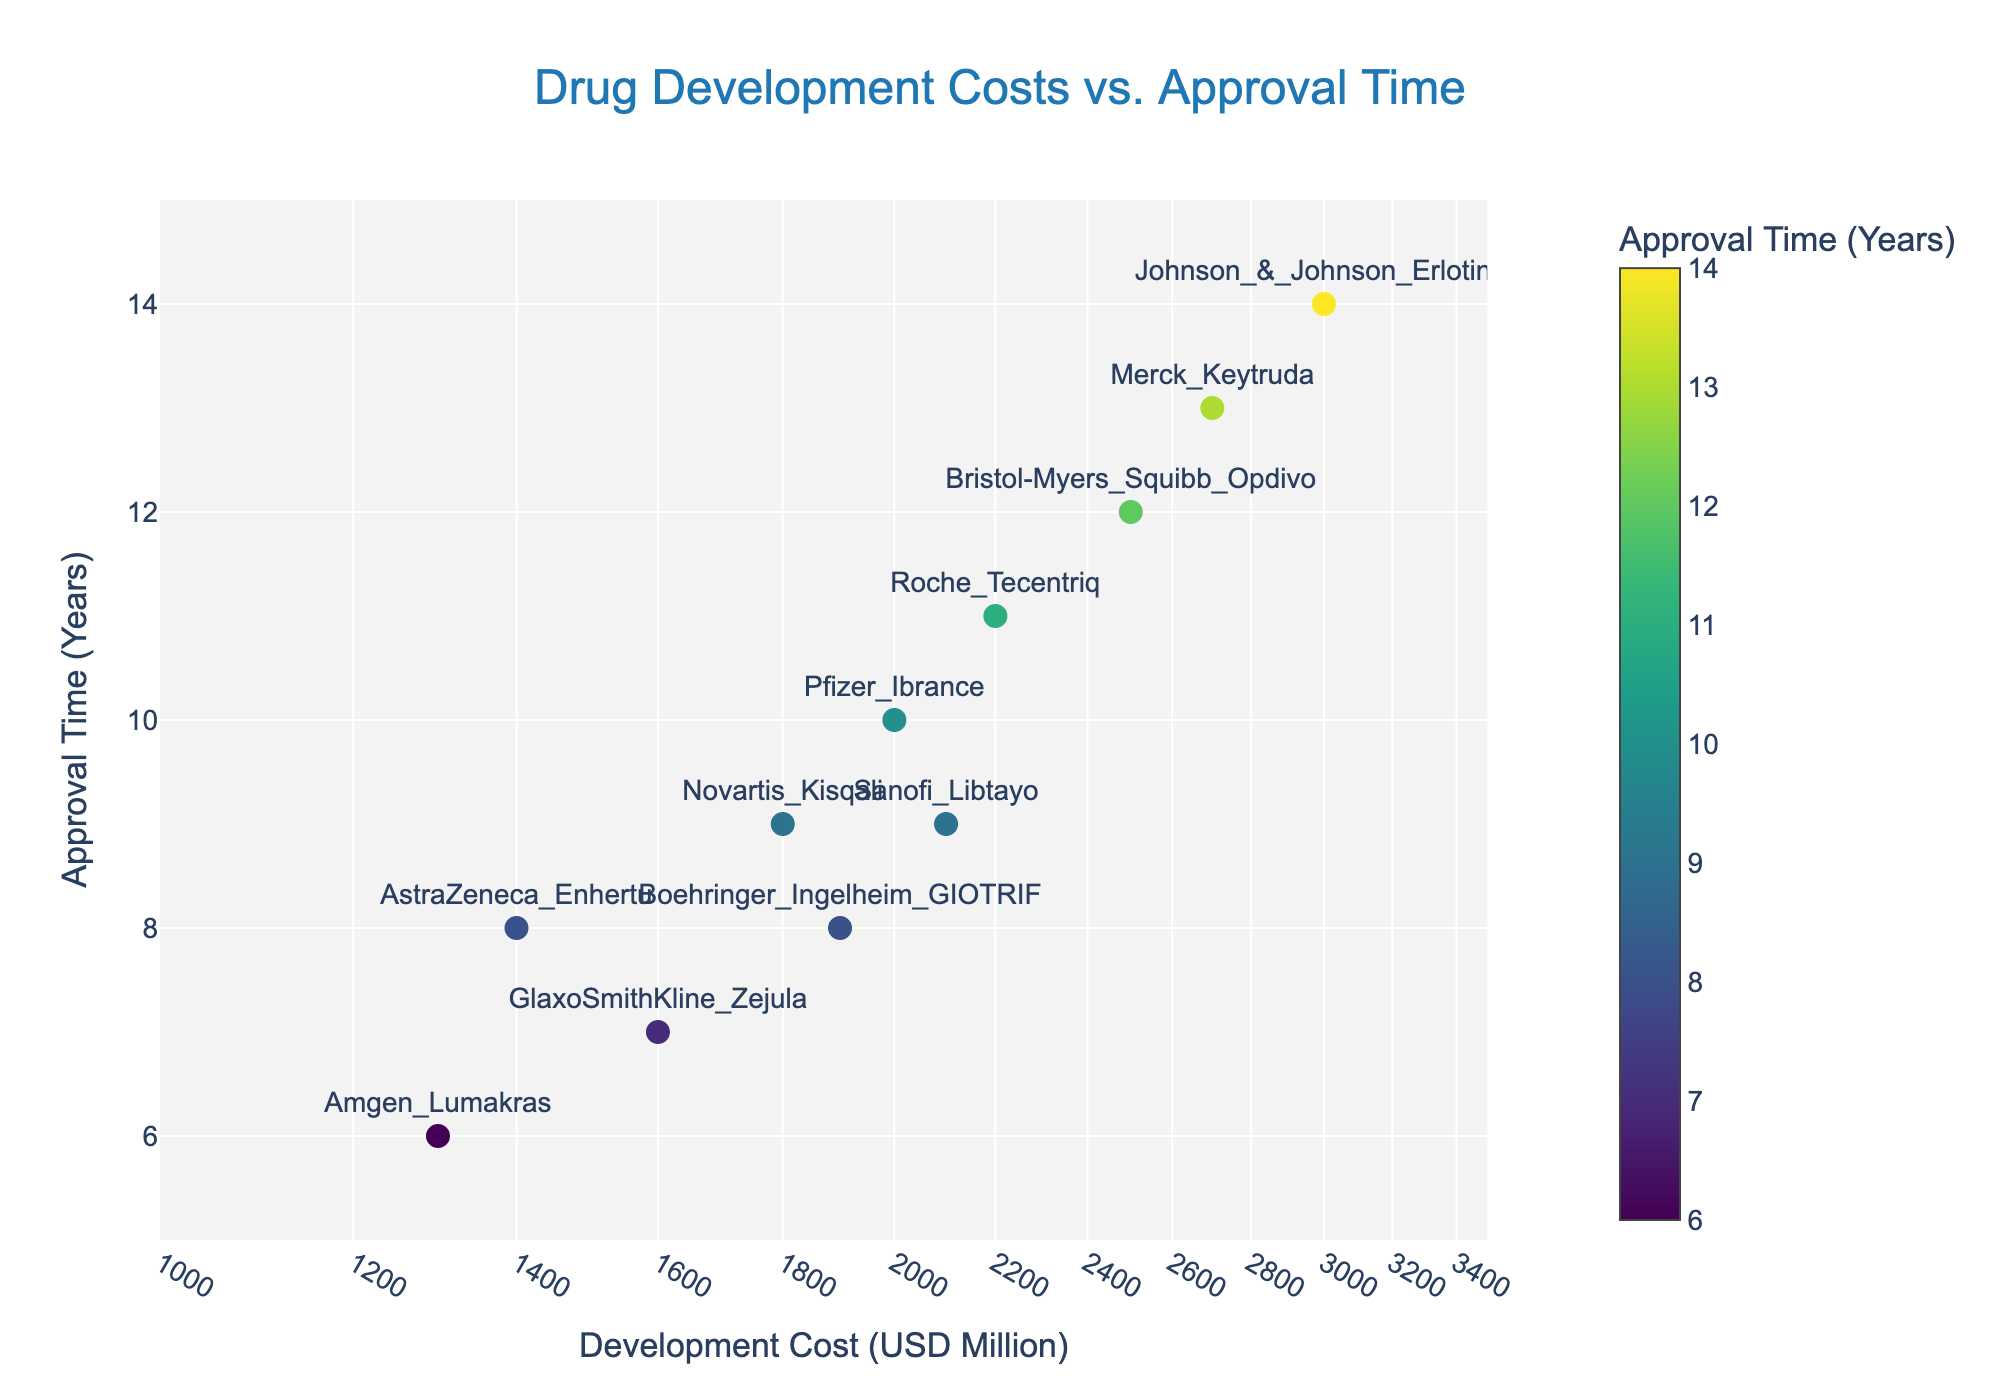What is the title of the plot? The title is located at the top center of the plot. It is a textual element designed to give viewers an overview of what the plot is about.
Answer: Drug Development Costs vs. Approval Time How many data points are shown in the plot? Count the number of markers displayed in the scatter plot. Each marker represents a drug. There are 11 drugs shown, so there should be 11 corresponding markers.
Answer: 11 Which drug has the highest development cost? Find the data point on the x-axis with the highest value. The data point should be labeled. Johnson & Johnson's Erlotinib is located at the far right, indicating the highest cost at 3000 million USD.
Answer: Johnson & Johnson Erlotinib Which drug took the longest time for approval? Identify the data point that has the highest value along the y-axis. The marker for Johnson & Johnson Erlotinib is positioned at 14 years on the y-axis, indicating the longest approval time.
Answer: Johnson & Johnson Erlotinib Which drug has the lowest approval time? Locate the data point with the smallest value on the y-axis. Amgen Lumakras is positioned at 6 years, indicating the shortest approval time.
Answer: Amgen Lumakras What is the color scale used to represent the approval time? The color scale is used to indicate the approval time in years. Look at the color bar next to the plot, which ranges from lighter to darker colors as time increases.
Answer: Viridis What is the average development cost of the drugs shown in the plot? Sum the development costs of all drugs and divide by the total number of drugs. Costs: 1400+2000+1800+2500+2200+2700+1600+3000+1900+2100+1300 = 22500. Average = 22500 / 11 ≈ 2045.45 million USD.
Answer: 2045.45 million USD Which drug had the highest development cost relative to its approval time? Calculate the cost-to-time ratio for each drug and find the highest value. Ratio = Cost/Time. Johnson & Johnson Erlotinib: 3000/14 ≈ 214.29, which is the highest ratio.
Answer: Johnson & Johnson Erlotinib Is there a correlation between development cost and approval time? Observe the general trend of the data points. If the markers generally form a line that slopes upward or downward, it indicates a correlation. Here, points are somewhat scattered but tend to show a loose positive correlation, implying a slight trend where higher costs may correspond to longer times.
Answer: Slight positive correlation What is the range of approval times displayed on the y-axis? The y-axis displays a range from 5 to 15 years. This can be read from the axis labels and the tick marks.
Answer: From 5 to 15 years 